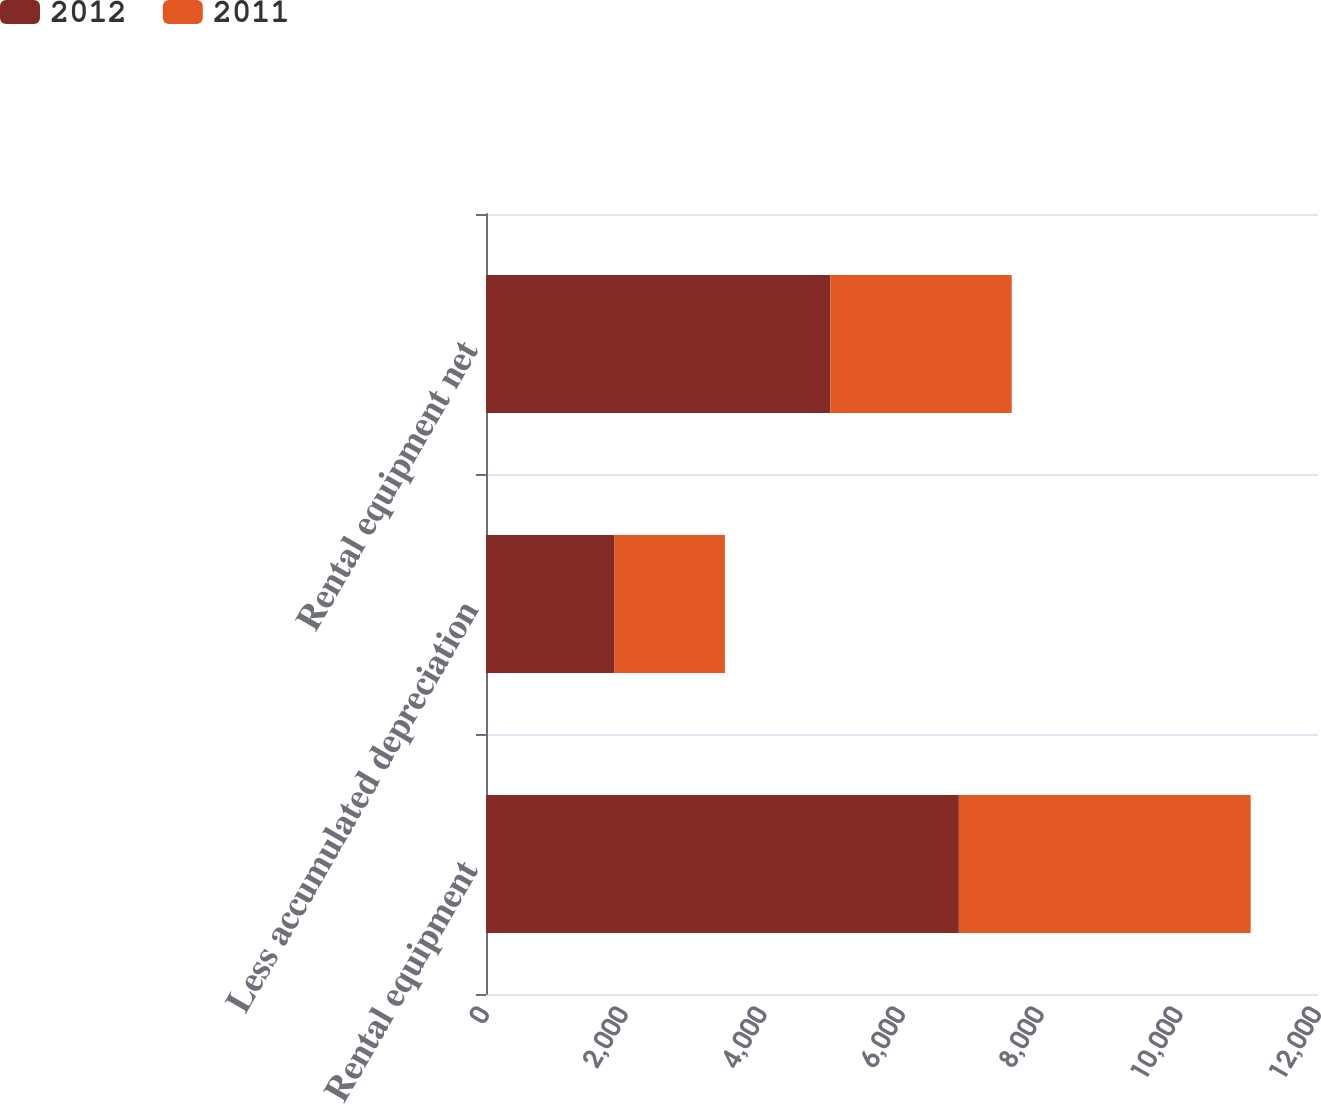Convert chart. <chart><loc_0><loc_0><loc_500><loc_500><stacked_bar_chart><ecel><fcel>Rental equipment<fcel>Less accumulated depreciation<fcel>Rental equipment net<nl><fcel>2012<fcel>6820<fcel>1854<fcel>4966<nl><fcel>2011<fcel>4209<fcel>1592<fcel>2617<nl></chart> 